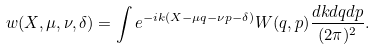Convert formula to latex. <formula><loc_0><loc_0><loc_500><loc_500>w ( X , \mu , \nu , \delta ) = \int e ^ { - i k ( X - \mu q - \nu p - \delta ) } W ( q , p ) \frac { d k d q d p } { ( 2 \pi ) ^ { 2 } } .</formula> 